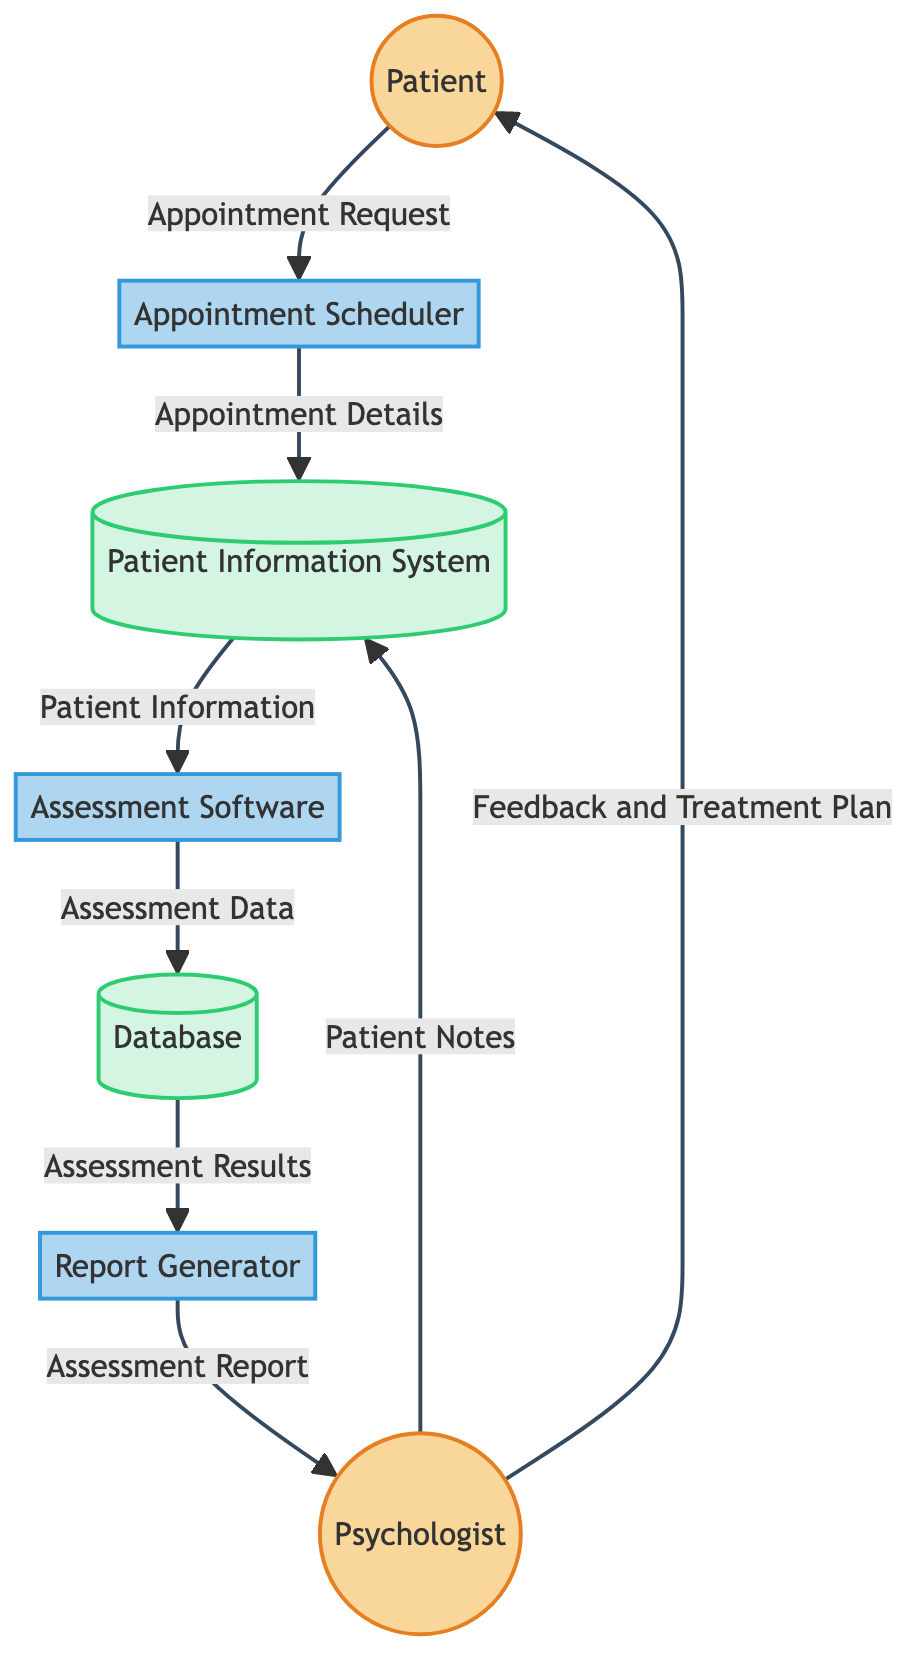What is the initial point of interaction for the Patient? The Patient initiates the process by sending an Appointment Request to the Appointment Scheduler, marking the beginning of the intake process.
Answer: Appointment Request How many processes are present in the diagram? There are three processes shown: Appointment Scheduler, Assessment Software, and Report Generator. This can be counted directly from the diagram.
Answer: Three What data flow occurs from the Patient Information System to the Assessment Software? The data flow carries Patient Information from the Patient Information System to the Assessment Software, which is essential for the assessment process.
Answer: Patient Information What type of entity is the Report Generator? The Report Generator is categorized as a process because it takes inputs from the Database to generate reports for the Psychologist.
Answer: Process What feedback does the Psychologist provide to the Patient? Following the assessment process, the Psychologist delivers Feedback and Treatment Plan to the Patient, concluding the flow of information.
Answer: Feedback and Treatment Plan Which external entity provides Patient Notes to the Patient Information System? The Psychologist provides the Patient Notes to the Patient Information System, which is critical for maintaining accurate patient records.
Answer: Psychologist What is the output of the Report Generator? The Report Generator produces an Assessment Report based on the results retrieved from the Database, which is shared with the Psychologist.
Answer: Assessment Report What type of data does the Database receive from the Assessment Software? The Database receives Assessment Data from the Assessment Software, which is necessary for generating comprehensive reports later.
Answer: Assessment Data Which data store is responsible for holding appointment details? The Patient Information System is responsible for holding Appointment Details received from the Appointment Scheduler, which is used throughout the intake process.
Answer: Patient Information System 